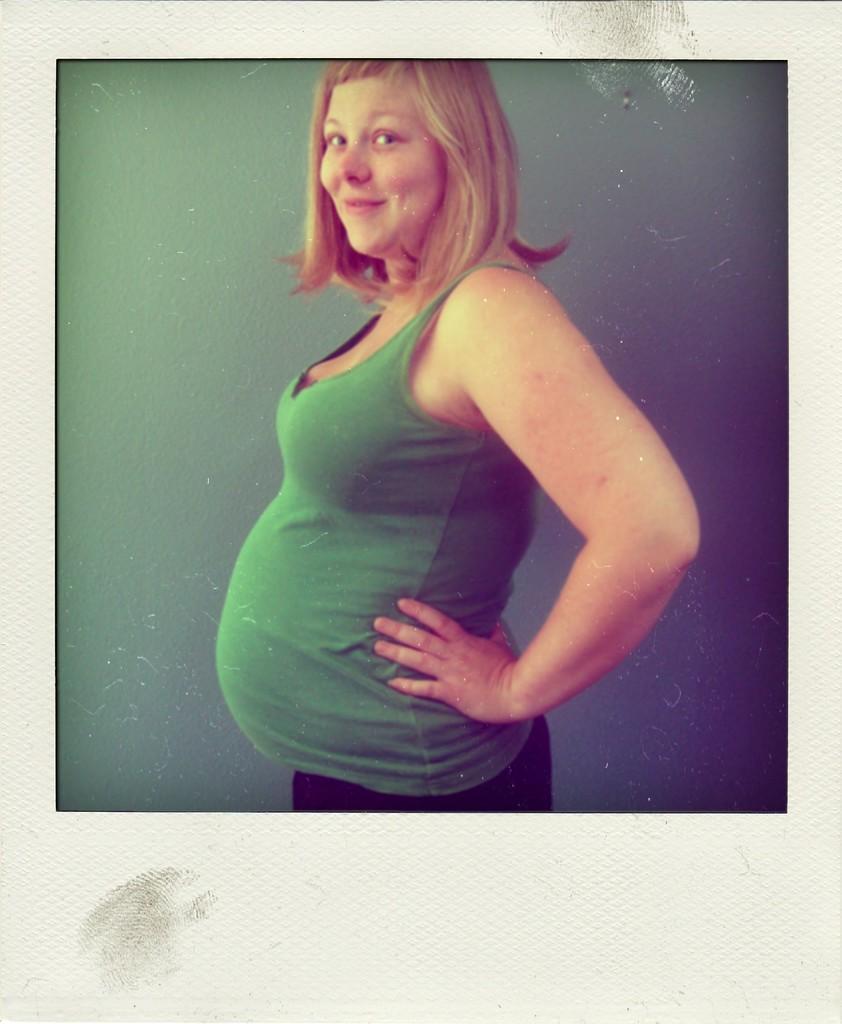In one or two sentences, can you explain what this image depicts? This is the photo of a lady and we can also see the background. 